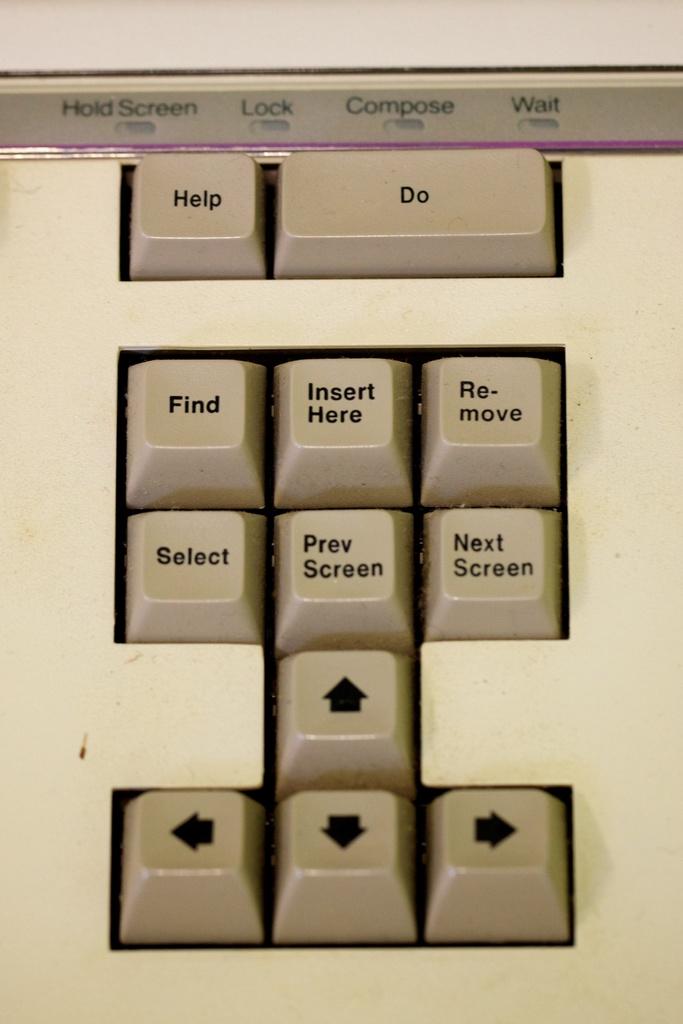What is the top right button supposed to do?
Your answer should be very brief. Do. What key is just below "find"?
Ensure brevity in your answer.  Select. 